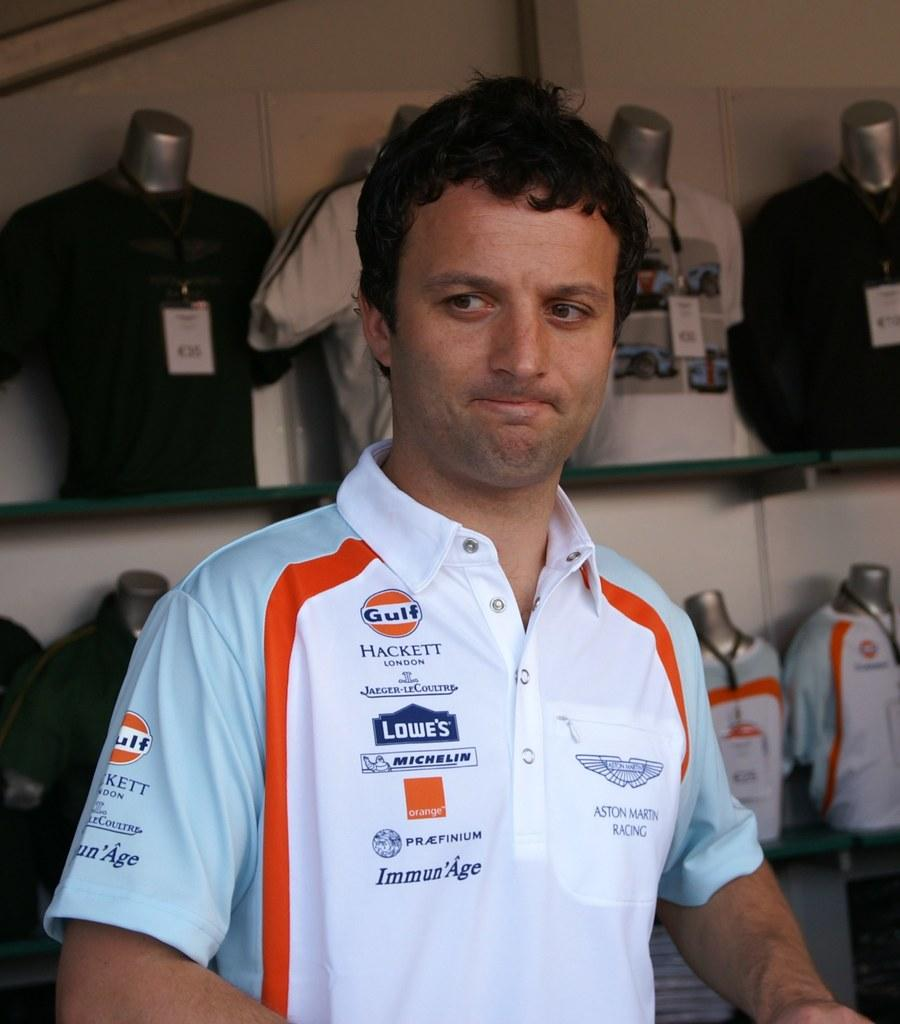<image>
Describe the image concisely. A man's pro racing shirt is covered with advertisements for Gulf, Lowe's and others. 